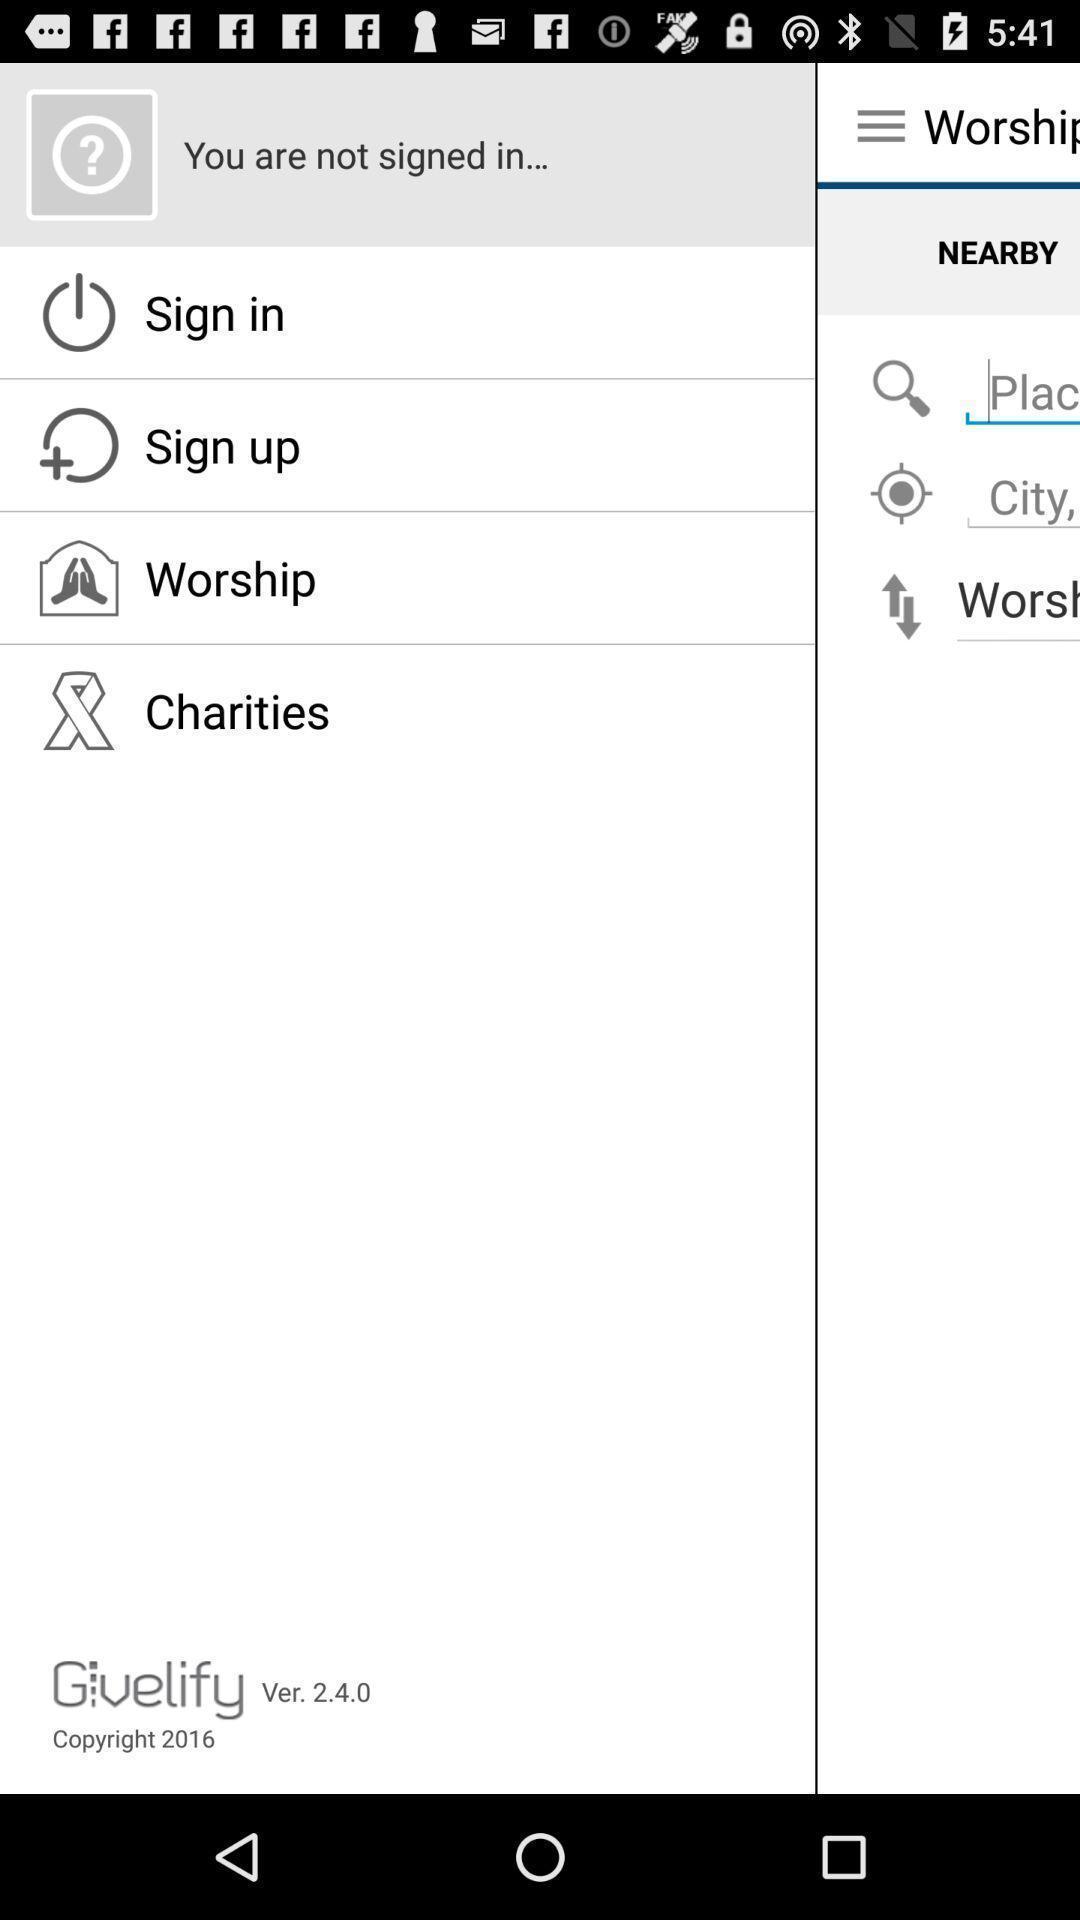What is the overall content of this screenshot? Window displaying a charity app. 